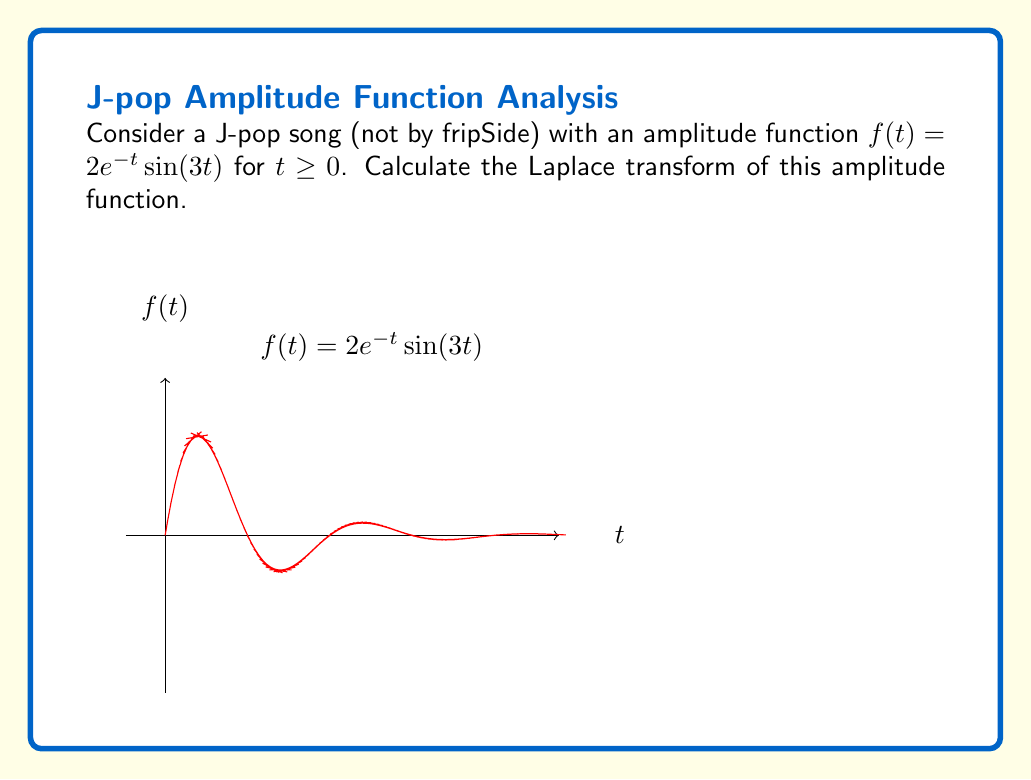What is the answer to this math problem? To find the Laplace transform of $f(t) = 2e^{-t}\sin(3t)$, we use the definition:

$$\mathcal{L}\{f(t)\} = F(s) = \int_0^{\infty} f(t)e^{-st} dt$$

Step 1: Substitute the given function into the integral:
$$F(s) = \int_0^{\infty} 2e^{-t}\sin(3t)e^{-st} dt$$

Step 2: Simplify the integrand:
$$F(s) = 2\int_0^{\infty} e^{-(s+1)t}\sin(3t) dt$$

Step 3: Use the Laplace transform formula for $e^{at}\sin(bt)$:
$$\mathcal{L}\{e^{at}\sin(bt)\} = \frac{b}{(s-a)^2 + b^2}$$

In our case, $a = -1$ and $b = 3$. Substituting these values:

$$F(s) = 2 \cdot \frac{3}{(s-(-1))^2 + 3^2} = \frac{6}{(s+1)^2 + 9}$$

Step 4: Simplify the final expression:
$$F(s) = \frac{6}{s^2 + 2s + 10}$$

This is the Laplace transform of the given J-pop song's amplitude function.
Answer: $F(s) = \frac{6}{s^2 + 2s + 10}$ 